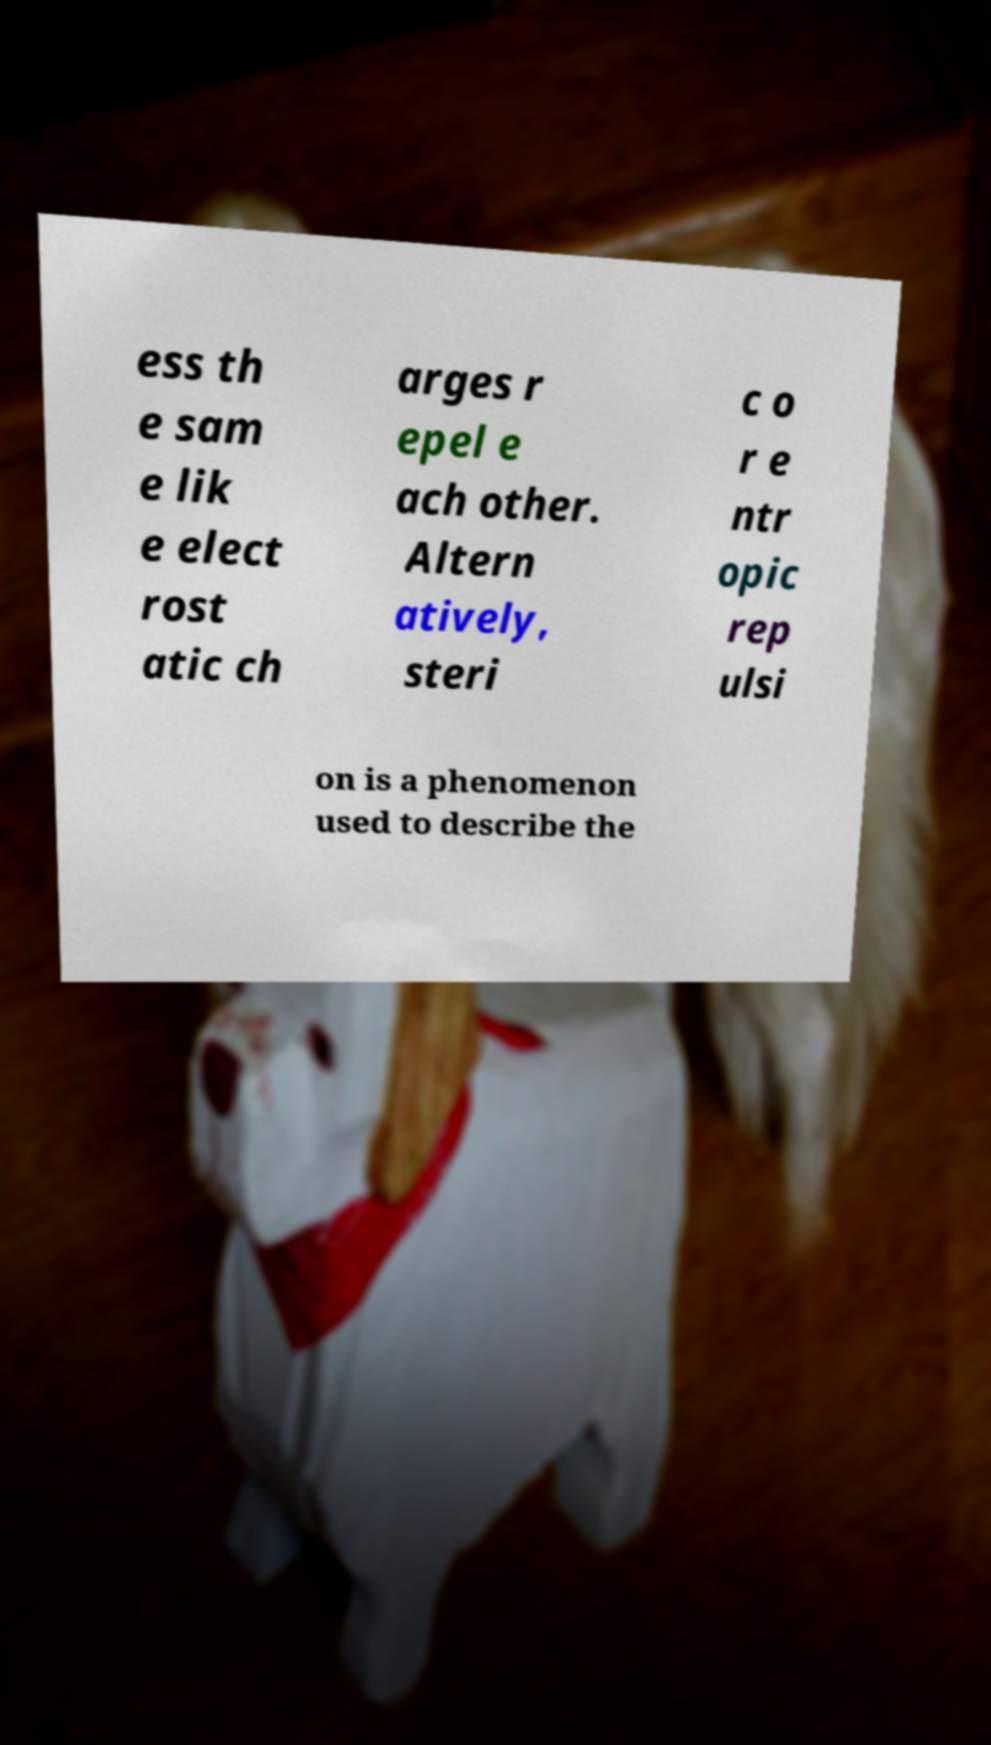Could you assist in decoding the text presented in this image and type it out clearly? ess th e sam e lik e elect rost atic ch arges r epel e ach other. Altern atively, steri c o r e ntr opic rep ulsi on is a phenomenon used to describe the 